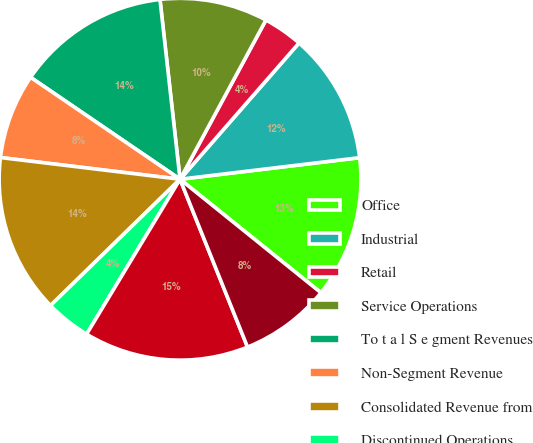Convert chart. <chart><loc_0><loc_0><loc_500><loc_500><pie_chart><fcel>Office<fcel>Industrial<fcel>Retail<fcel>Service Operations<fcel>To t a l S e gment Revenues<fcel>Non-Segment Revenue<fcel>Consolidated Revenue from<fcel>Discontinued Operations<fcel>Consolidated Revenue<fcel>Services Operations<nl><fcel>12.69%<fcel>11.67%<fcel>3.55%<fcel>9.64%<fcel>13.7%<fcel>7.61%<fcel>14.21%<fcel>4.06%<fcel>14.72%<fcel>8.12%<nl></chart> 